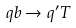<formula> <loc_0><loc_0><loc_500><loc_500>q b \to q ^ { \prime } T</formula> 